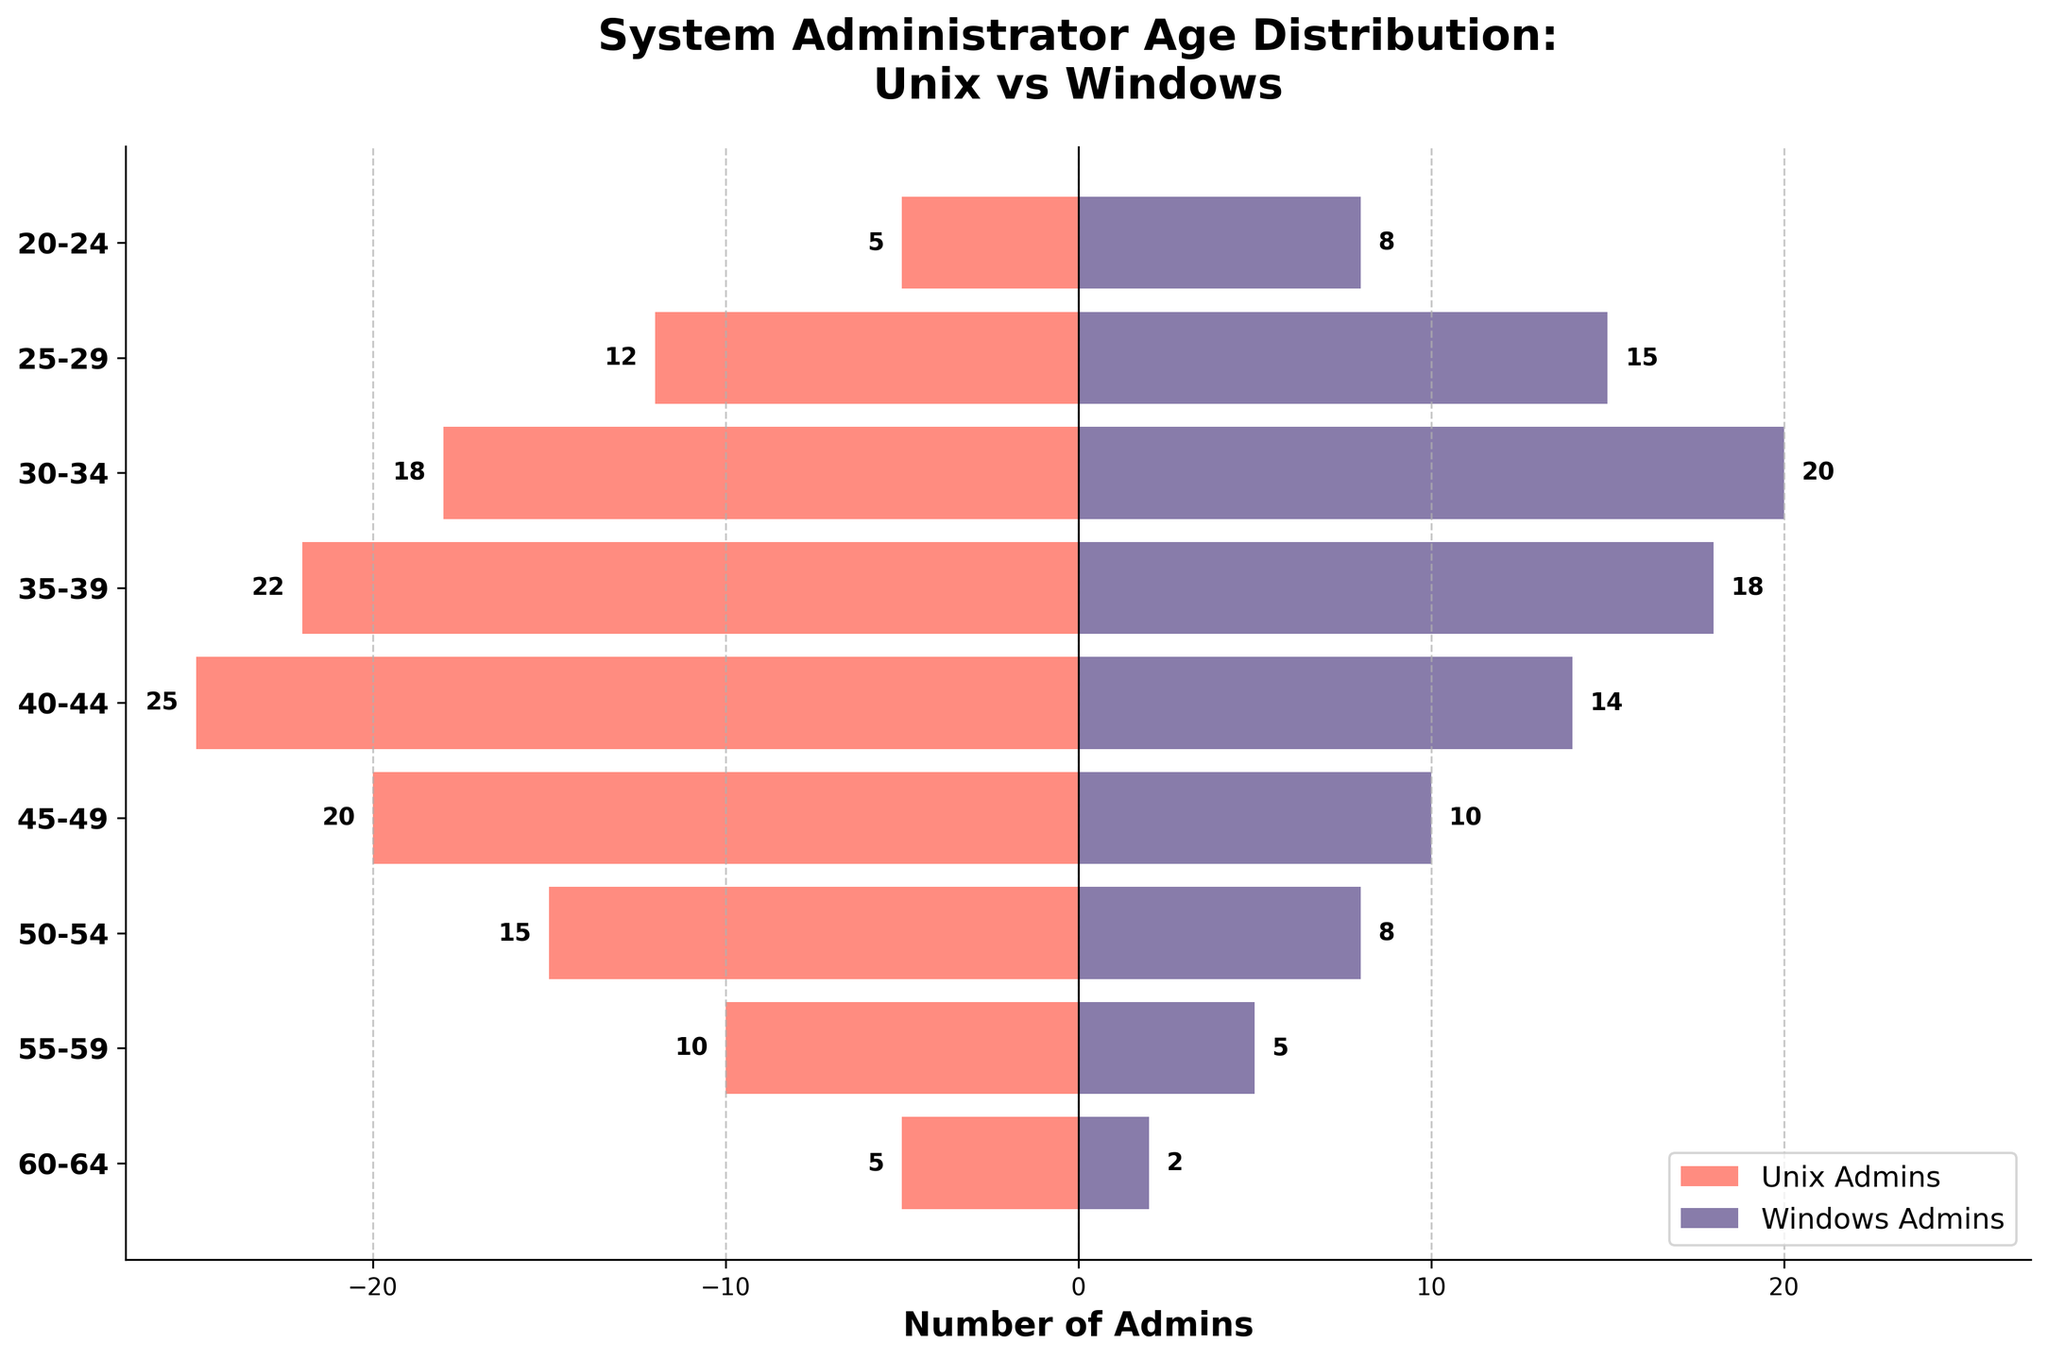What's the title of the figure? The title of the figure is usually displayed at the top and summarizes the content of the plot. In this case, it can be found above the plot area.
Answer: System Administrator Age Distribution: Unix vs Windows What does the x-axis represent? The x-axis in this plot shows the number of administrators. This can be understood from the labels and the context of the bars showing counts.
Answer: Number of Admins How many Unix administrators are in the 30-34 age group? To find the number of Unix administrators in this age group, locate the 30-34 age group on the y-axis and look at the corresponding horizontal bar on the left side. The label at the end of the bar states this number.
Answer: 18 Which age group has the highest count of Windows administrators? To determine the age group with the highest count of Windows administrators, look along the bars on the right side (Windows Admins) and identify which is the longest, then check the corresponding age group.
Answer: 30-34 What's the difference in the number of administrators between the 20-24 and 40-44 age groups for Unix administrators? First, find the number of Unix administrators in the 20-24 age group, which is 5, and then in the 40-44 age group, which is 25. Subtract the smaller number from the larger one to get the difference.
Answer: 20 Which age group shows a higher number of Unix administrators compared to Windows administrators? By checking each age group from the y-axis and comparing the lengths of the bars on both sides (Unix admins on the left and Windows admins on the right), we can find that several age groups fit this criterion. Specifically, the 35-39, 40-44, 45-49, and 55-59 age groups show higher numbers of Unix administrators.
Answer: 35-39, 40-44, 45-49, 55-59 What’s the total number of Windows administrators across all age groups? To find this, sum the counts of Windows administrators from all age groups as indicated by the bars on the right side of the plot: 8 + 15 + 20 + 18 + 14 + 10 + 8 + 5 + 2 = 100.
Answer: 100 What's the average number of Unix administrators across all age groups? To calculate the average, sum the counts of Unix administrators from all age groups: 5 + 12 + 18 + 22 + 25 + 20 + 15 + 10 + 5 = 132. Then divide this sum by the number of age groups, which is 9. So, 132 / 9 = 14.67.
Answer: 14.67 Which age group has the least difference in the number of Unix and Windows administrators? For each age group, find the absolute difference between the number of Unix and Windows administrators. The smallest difference appears in the 50-54 age group, where the difference is 15 (Unix) - 8 (Windows) = 7.
Answer: 50-54 Which side of the plot shows a decreasing trend in the number of administrators as the age increases? By examining the left side (Unix Admins) and right side (Windows Admins) of the plot, we can observe that the right side (Windows Admins) shows a consistent decreasing trend as the age groups progress from young to old.
Answer: Windows Admins 